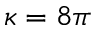Convert formula to latex. <formula><loc_0><loc_0><loc_500><loc_500>\kappa = 8 \pi</formula> 